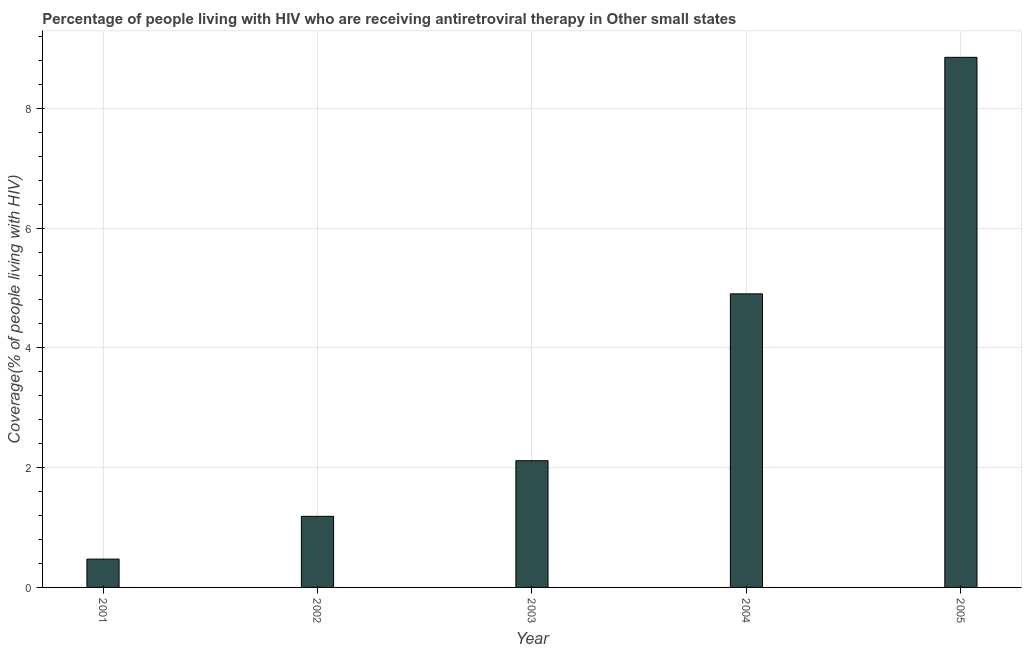Does the graph contain grids?
Make the answer very short. Yes. What is the title of the graph?
Ensure brevity in your answer.  Percentage of people living with HIV who are receiving antiretroviral therapy in Other small states. What is the label or title of the Y-axis?
Ensure brevity in your answer.  Coverage(% of people living with HIV). What is the antiretroviral therapy coverage in 2002?
Your response must be concise. 1.19. Across all years, what is the maximum antiretroviral therapy coverage?
Ensure brevity in your answer.  8.85. Across all years, what is the minimum antiretroviral therapy coverage?
Keep it short and to the point. 0.47. In which year was the antiretroviral therapy coverage maximum?
Your answer should be compact. 2005. In which year was the antiretroviral therapy coverage minimum?
Provide a short and direct response. 2001. What is the sum of the antiretroviral therapy coverage?
Make the answer very short. 17.53. What is the difference between the antiretroviral therapy coverage in 2004 and 2005?
Your answer should be compact. -3.95. What is the average antiretroviral therapy coverage per year?
Make the answer very short. 3.5. What is the median antiretroviral therapy coverage?
Ensure brevity in your answer.  2.12. In how many years, is the antiretroviral therapy coverage greater than 0.8 %?
Your answer should be compact. 4. Do a majority of the years between 2002 and 2004 (inclusive) have antiretroviral therapy coverage greater than 8.4 %?
Make the answer very short. No. What is the ratio of the antiretroviral therapy coverage in 2004 to that in 2005?
Make the answer very short. 0.55. Is the difference between the antiretroviral therapy coverage in 2001 and 2002 greater than the difference between any two years?
Provide a succinct answer. No. What is the difference between the highest and the second highest antiretroviral therapy coverage?
Provide a succinct answer. 3.95. Is the sum of the antiretroviral therapy coverage in 2002 and 2004 greater than the maximum antiretroviral therapy coverage across all years?
Your answer should be compact. No. What is the difference between the highest and the lowest antiretroviral therapy coverage?
Make the answer very short. 8.38. How many bars are there?
Offer a terse response. 5. How many years are there in the graph?
Your response must be concise. 5. Are the values on the major ticks of Y-axis written in scientific E-notation?
Give a very brief answer. No. What is the Coverage(% of people living with HIV) of 2001?
Ensure brevity in your answer.  0.47. What is the Coverage(% of people living with HIV) of 2002?
Make the answer very short. 1.19. What is the Coverage(% of people living with HIV) in 2003?
Offer a terse response. 2.12. What is the Coverage(% of people living with HIV) of 2004?
Your answer should be very brief. 4.9. What is the Coverage(% of people living with HIV) of 2005?
Ensure brevity in your answer.  8.85. What is the difference between the Coverage(% of people living with HIV) in 2001 and 2002?
Keep it short and to the point. -0.71. What is the difference between the Coverage(% of people living with HIV) in 2001 and 2003?
Provide a short and direct response. -1.64. What is the difference between the Coverage(% of people living with HIV) in 2001 and 2004?
Provide a succinct answer. -4.43. What is the difference between the Coverage(% of people living with HIV) in 2001 and 2005?
Offer a terse response. -8.38. What is the difference between the Coverage(% of people living with HIV) in 2002 and 2003?
Make the answer very short. -0.93. What is the difference between the Coverage(% of people living with HIV) in 2002 and 2004?
Your answer should be very brief. -3.71. What is the difference between the Coverage(% of people living with HIV) in 2002 and 2005?
Give a very brief answer. -7.66. What is the difference between the Coverage(% of people living with HIV) in 2003 and 2004?
Your answer should be compact. -2.79. What is the difference between the Coverage(% of people living with HIV) in 2003 and 2005?
Your answer should be compact. -6.74. What is the difference between the Coverage(% of people living with HIV) in 2004 and 2005?
Keep it short and to the point. -3.95. What is the ratio of the Coverage(% of people living with HIV) in 2001 to that in 2002?
Your answer should be very brief. 0.4. What is the ratio of the Coverage(% of people living with HIV) in 2001 to that in 2003?
Provide a short and direct response. 0.22. What is the ratio of the Coverage(% of people living with HIV) in 2001 to that in 2004?
Make the answer very short. 0.1. What is the ratio of the Coverage(% of people living with HIV) in 2001 to that in 2005?
Provide a short and direct response. 0.05. What is the ratio of the Coverage(% of people living with HIV) in 2002 to that in 2003?
Make the answer very short. 0.56. What is the ratio of the Coverage(% of people living with HIV) in 2002 to that in 2004?
Give a very brief answer. 0.24. What is the ratio of the Coverage(% of people living with HIV) in 2002 to that in 2005?
Give a very brief answer. 0.13. What is the ratio of the Coverage(% of people living with HIV) in 2003 to that in 2004?
Offer a terse response. 0.43. What is the ratio of the Coverage(% of people living with HIV) in 2003 to that in 2005?
Provide a succinct answer. 0.24. What is the ratio of the Coverage(% of people living with HIV) in 2004 to that in 2005?
Keep it short and to the point. 0.55. 